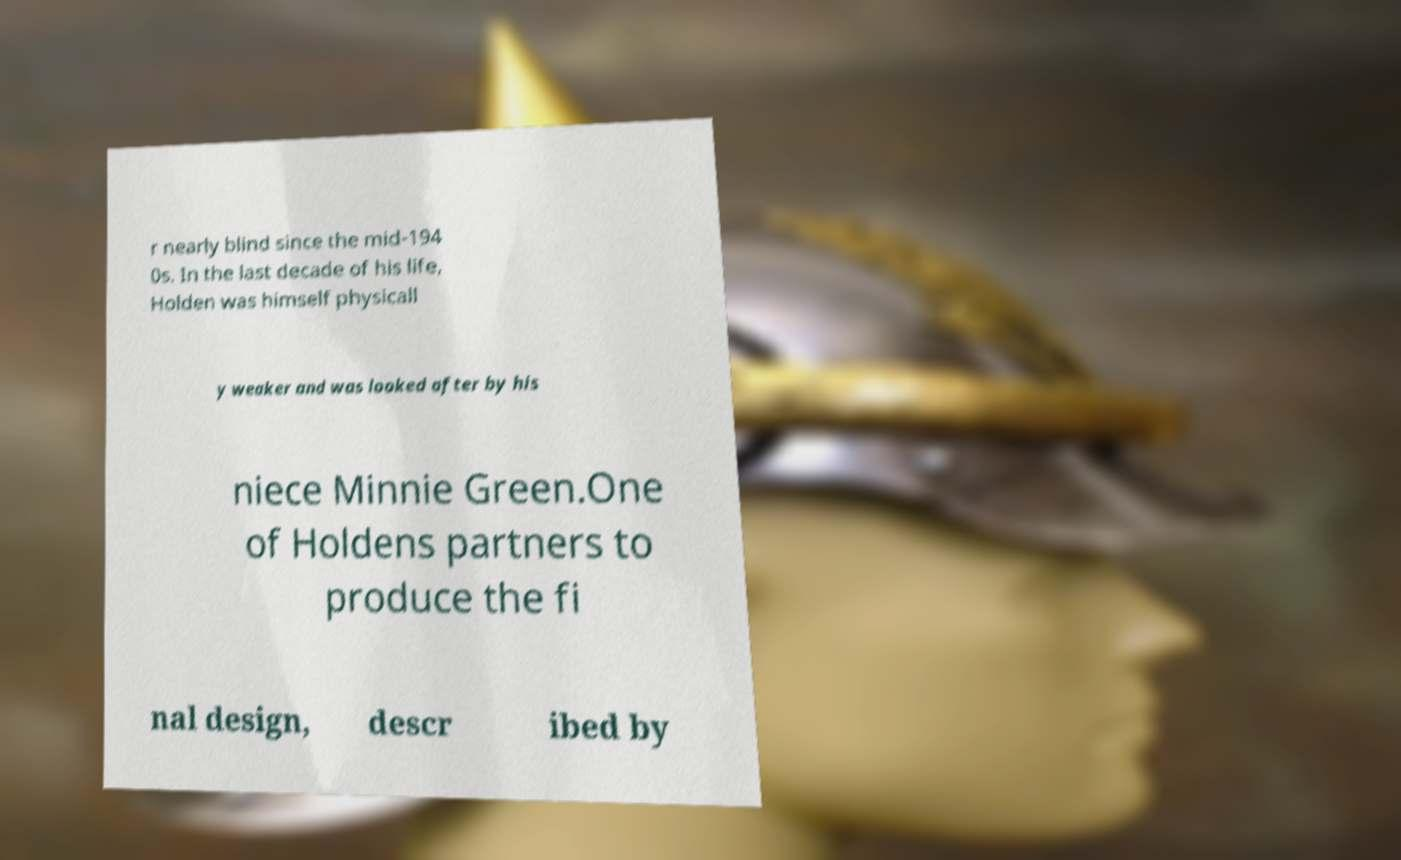What messages or text are displayed in this image? I need them in a readable, typed format. r nearly blind since the mid-194 0s. In the last decade of his life, Holden was himself physicall y weaker and was looked after by his niece Minnie Green.One of Holdens partners to produce the fi nal design, descr ibed by 